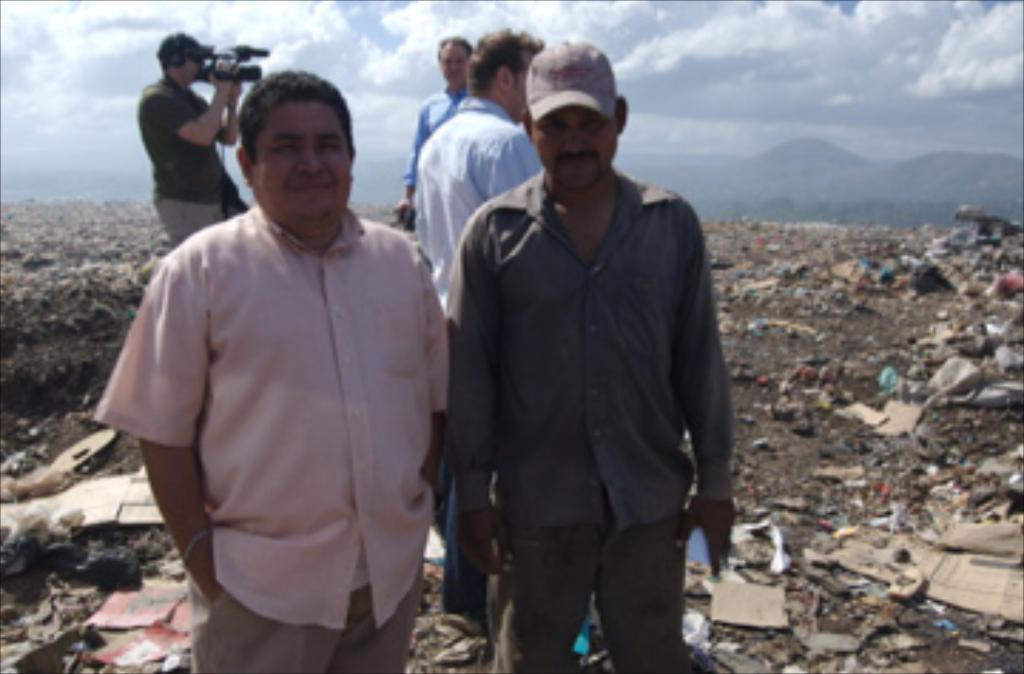How many people are in the image? There are five persons in the image. What is happening on the ground in the image? There is garbage on the ground in the image. What is the man in the image doing? A man is taking a video in the image. What type of landscape can be seen in the image? There are hills visible in the image. What is the weather like in the image? The sky is cloudy in the image. What grade is the teacher giving to the students in the image? There is no teacher or students present in the image, and therefore no grade can be given. What type of food is being cooked in the image? There is no cooking or food preparation happening in the image. What type of medical facility is visible in the image? There is no hospital or medical facility present in the image. 